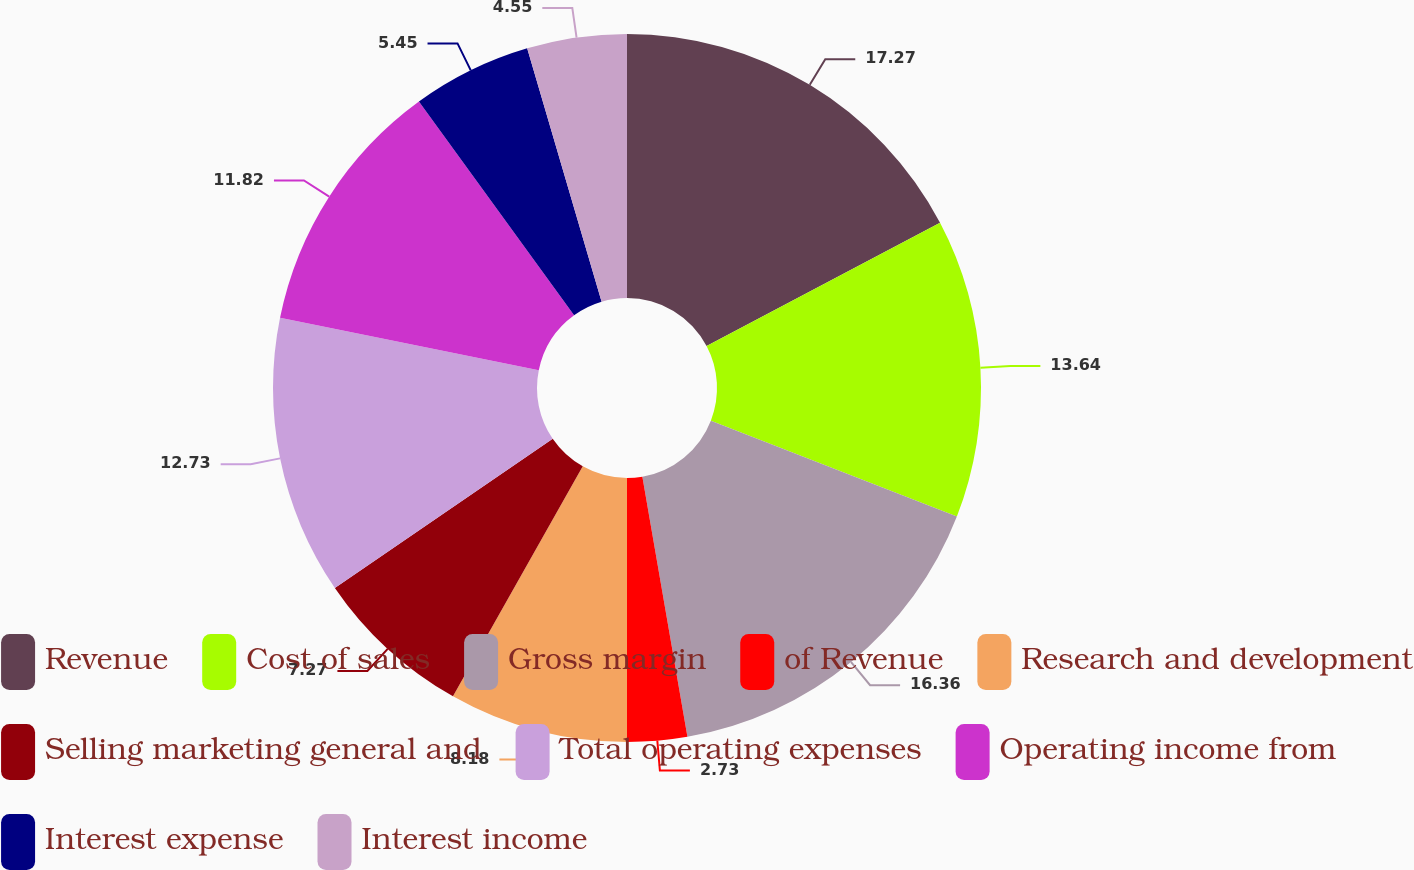Convert chart. <chart><loc_0><loc_0><loc_500><loc_500><pie_chart><fcel>Revenue<fcel>Cost of sales<fcel>Gross margin<fcel>of Revenue<fcel>Research and development<fcel>Selling marketing general and<fcel>Total operating expenses<fcel>Operating income from<fcel>Interest expense<fcel>Interest income<nl><fcel>17.27%<fcel>13.64%<fcel>16.36%<fcel>2.73%<fcel>8.18%<fcel>7.27%<fcel>12.73%<fcel>11.82%<fcel>5.45%<fcel>4.55%<nl></chart> 